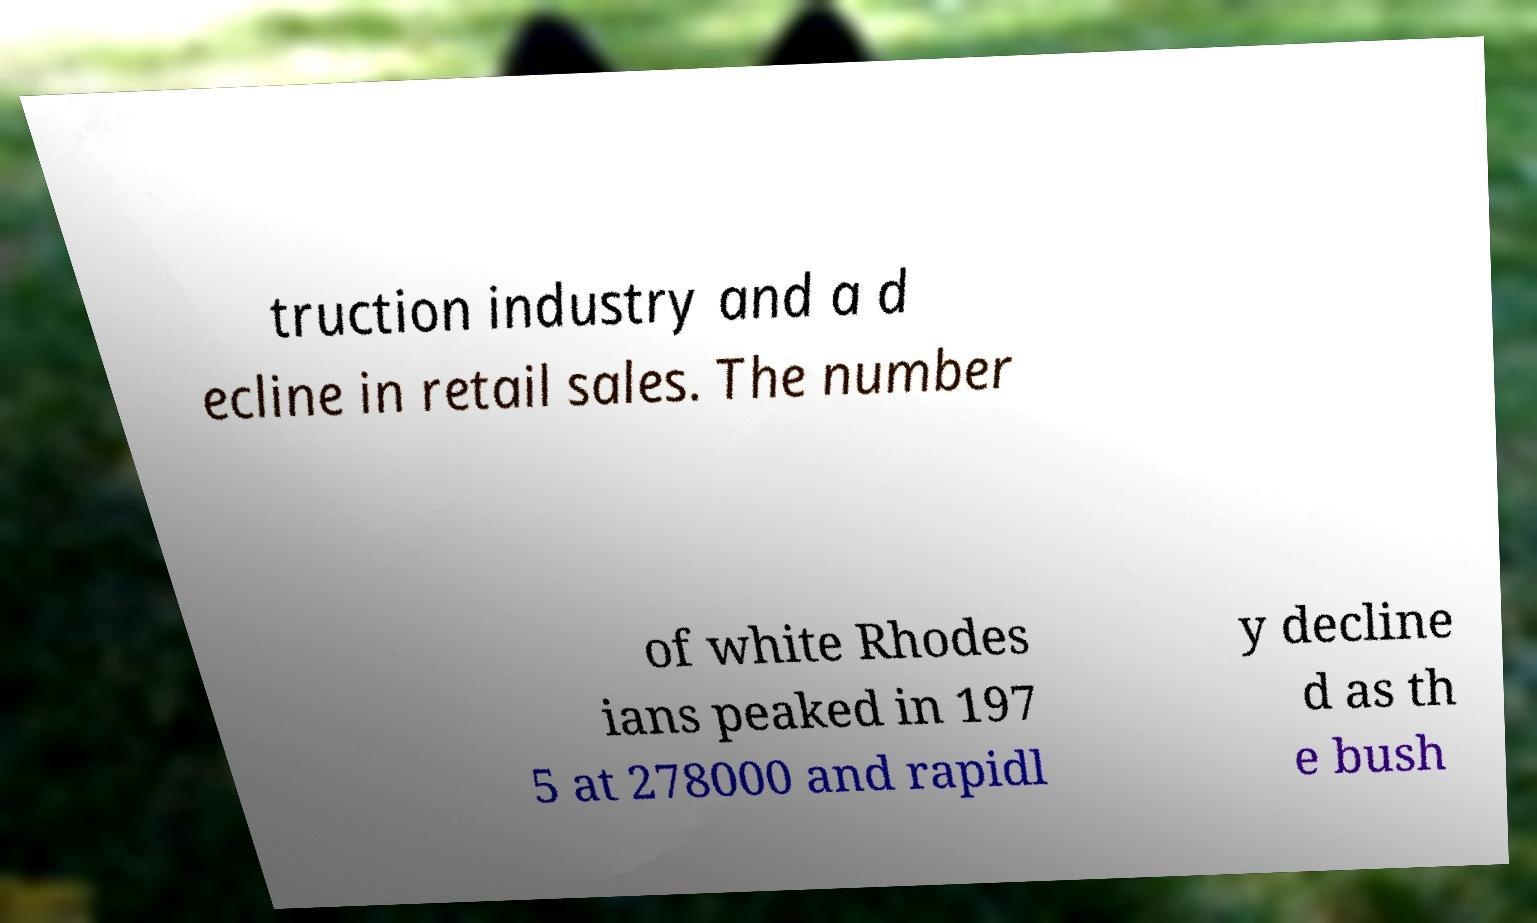Could you assist in decoding the text presented in this image and type it out clearly? truction industry and a d ecline in retail sales. The number of white Rhodes ians peaked in 197 5 at 278000 and rapidl y decline d as th e bush 